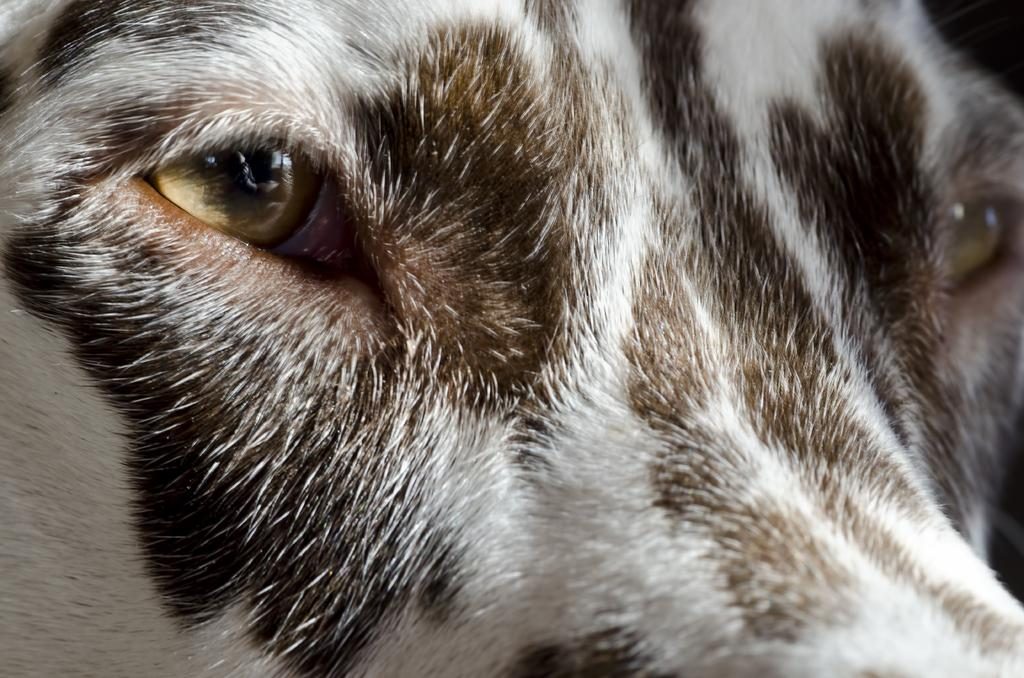What type of living creature is present in the image? There is an animal in the image. What is the reason for the dust in the image? There is no dust present in the image, as the only fact provided is that there is an animal in the image. Can you see an airplane in the image? There is no mention of an airplane in the provided facts, so we cannot determine if one is present in the image. 